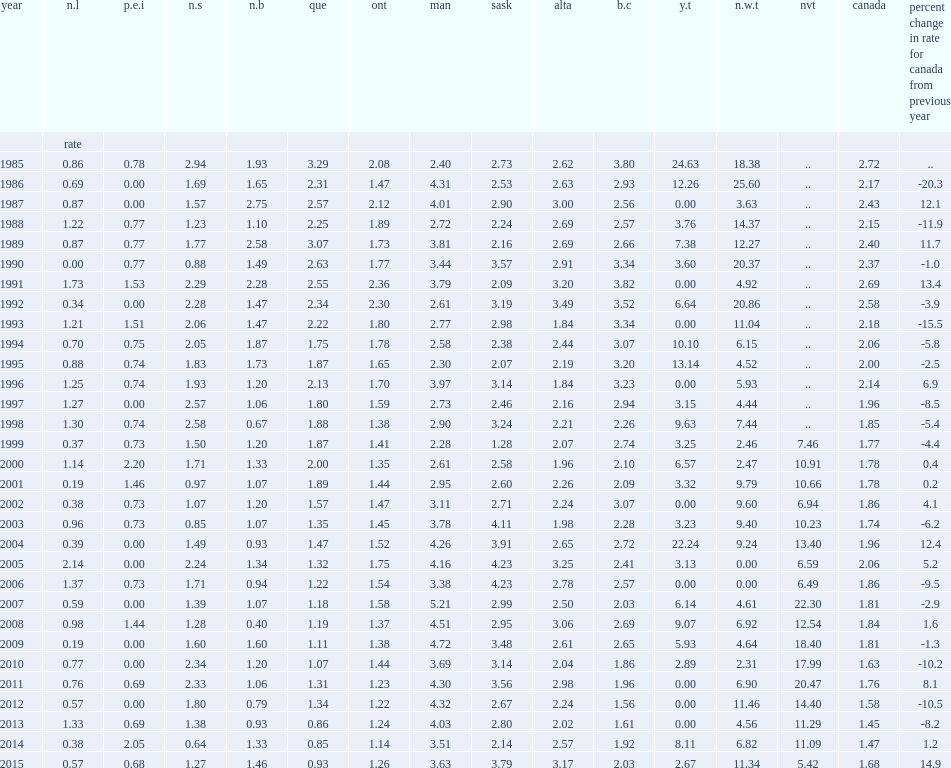Which province recorded the highest homicide rate in 2015? Sask. List the provinces that recorded the second and third homicide rate among the provinces in 2015 respectively. Man alta. What was the increased rate of nova scotia's homicide rate in 2015? 0.984375. What were the percentages of the rates of homicides in the northwest territories ,nunavut and yukon in 2015 respectively? 11.34 5.42 2.67. Which year did nunavut get the lowest reported rate since becoming a territory in 1999? 2015.0. List the provinces that reported the lowest three homicide rates. N.l p.e.i que. 